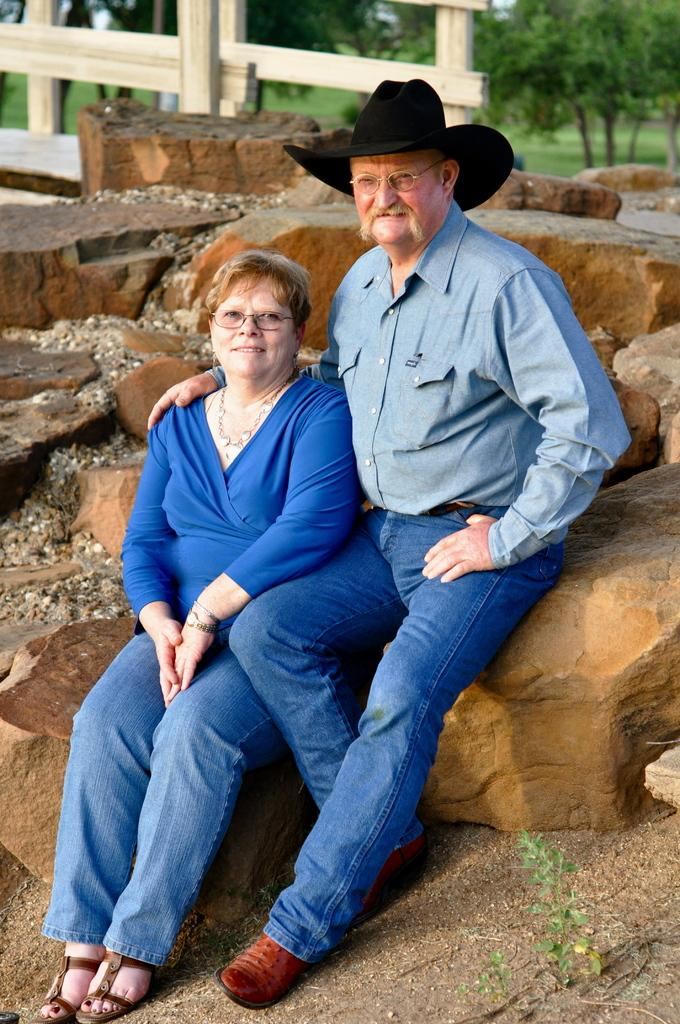How many people are sitting on the rocks in the image? There are two persons sitting on the rocks in the image. Can you describe the clothing of one of the persons? One of the persons is wearing a hat. What type of natural formation can be seen behind the persons? There are rocks visible behind the persons. What can be seen in the background of the image? There are trees and a wooden fence in the background. What type of sail can be seen in the image? There is no sail present in the image. How many steps are visible in the image? There are no steps visible in the image. 